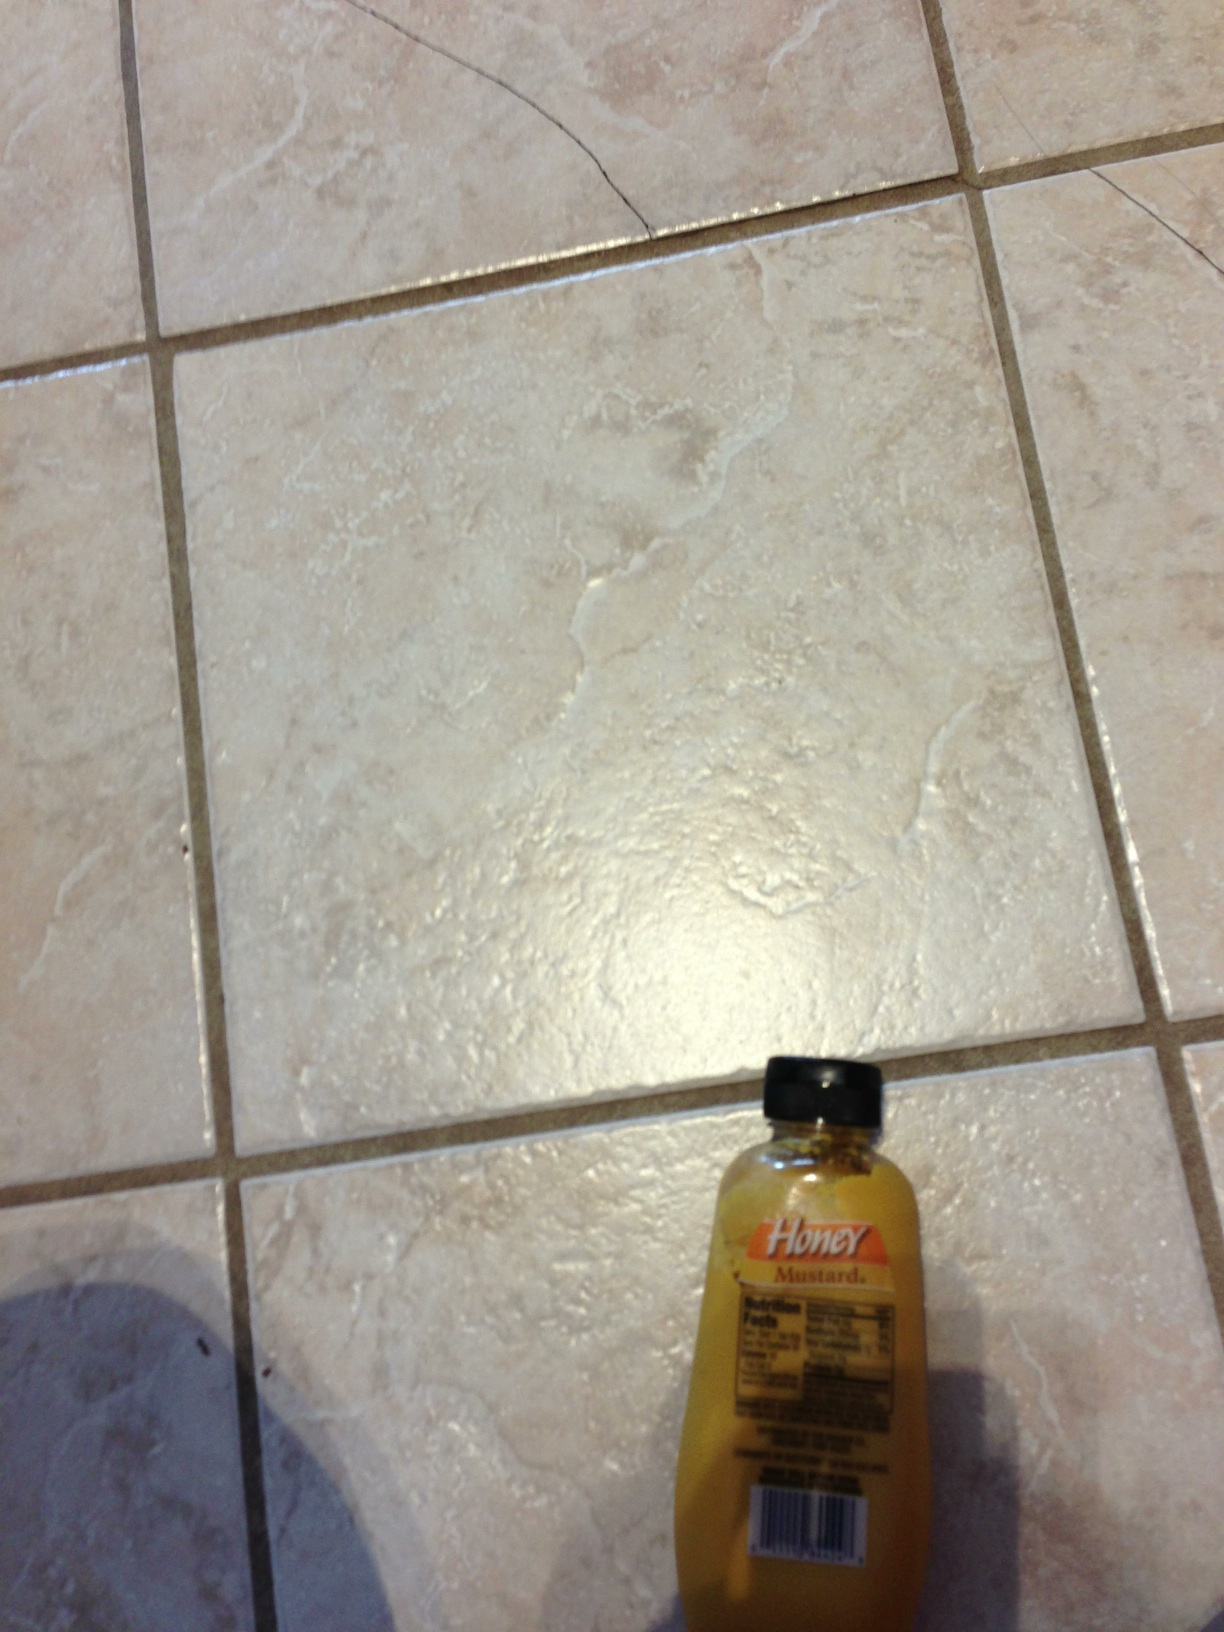What are some unique ways to use honey mustard? You can use honey mustard in several unique ways. Try it as a glaze for roasted vegetables, a marinade for grilled chicken, or a base for a tangy coleslaw. You can also mix it into mashed potatoes for a zesty kick or use it as a pizza drizzle for a sweet and savory contrast. 